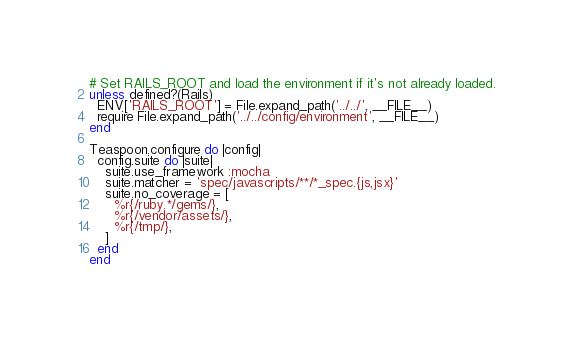<code> <loc_0><loc_0><loc_500><loc_500><_Ruby_># Set RAILS_ROOT and load the environment if it's not already loaded.
unless defined?(Rails)
  ENV['RAILS_ROOT'] = File.expand_path('../../', __FILE__)
  require File.expand_path('../../config/environment', __FILE__)
end

Teaspoon.configure do |config|
  config.suite do |suite|
    suite.use_framework :mocha
    suite.matcher = 'spec/javascripts/**/*_spec.{js,jsx}'
    suite.no_coverage = [
      %r{/ruby.*/gems/},
      %r{/vendor/assets/},
      %r{/tmp/},
    ]
  end
end
</code> 